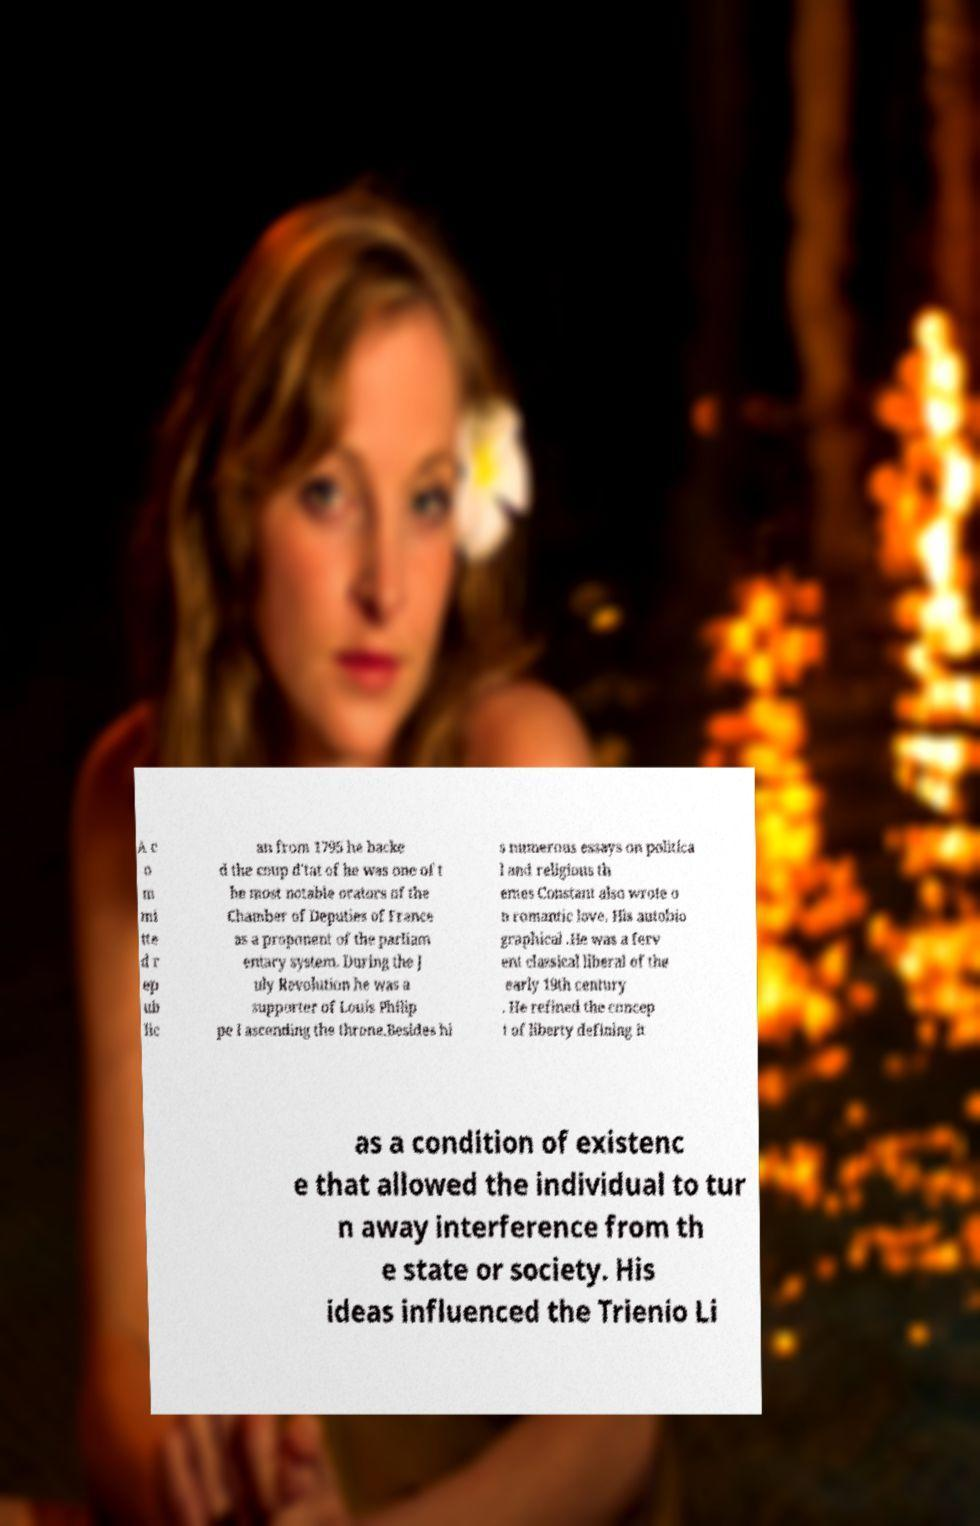There's text embedded in this image that I need extracted. Can you transcribe it verbatim? A c o m mi tte d r ep ub lic an from 1795 he backe d the coup d'tat of he was one of t he most notable orators of the Chamber of Deputies of France as a proponent of the parliam entary system. During the J uly Revolution he was a supporter of Louis Philip pe I ascending the throne.Besides hi s numerous essays on politica l and religious th emes Constant also wrote o n romantic love. His autobio graphical .He was a ferv ent classical liberal of the early 19th century . He refined the concep t of liberty defining it as a condition of existenc e that allowed the individual to tur n away interference from th e state or society. His ideas influenced the Trienio Li 